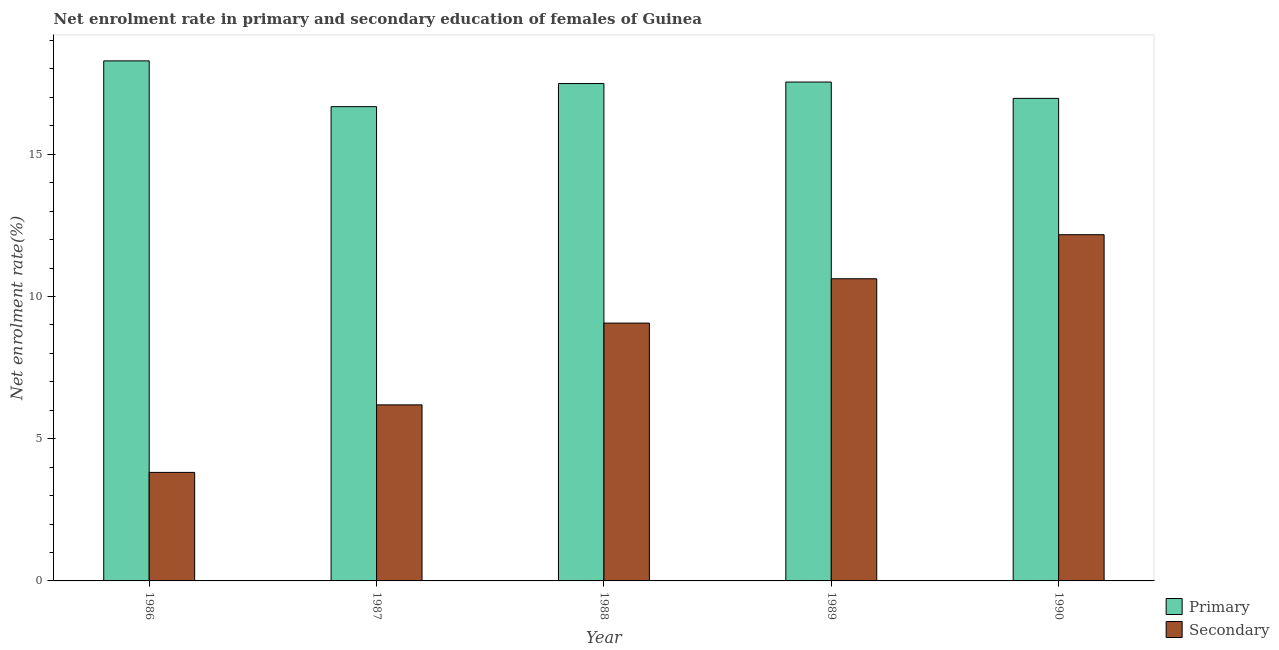How many groups of bars are there?
Offer a very short reply. 5. Are the number of bars per tick equal to the number of legend labels?
Provide a succinct answer. Yes. How many bars are there on the 3rd tick from the left?
Ensure brevity in your answer.  2. What is the enrollment rate in secondary education in 1988?
Provide a succinct answer. 9.06. Across all years, what is the maximum enrollment rate in primary education?
Your answer should be very brief. 18.28. Across all years, what is the minimum enrollment rate in primary education?
Give a very brief answer. 16.67. What is the total enrollment rate in primary education in the graph?
Your response must be concise. 86.94. What is the difference between the enrollment rate in secondary education in 1986 and that in 1989?
Your answer should be very brief. -6.81. What is the difference between the enrollment rate in primary education in 1986 and the enrollment rate in secondary education in 1987?
Make the answer very short. 1.61. What is the average enrollment rate in secondary education per year?
Give a very brief answer. 8.37. In the year 1990, what is the difference between the enrollment rate in primary education and enrollment rate in secondary education?
Provide a succinct answer. 0. In how many years, is the enrollment rate in secondary education greater than 4 %?
Offer a terse response. 4. What is the ratio of the enrollment rate in secondary education in 1986 to that in 1989?
Provide a succinct answer. 0.36. Is the enrollment rate in secondary education in 1987 less than that in 1988?
Provide a short and direct response. Yes. What is the difference between the highest and the second highest enrollment rate in secondary education?
Your answer should be very brief. 1.55. What is the difference between the highest and the lowest enrollment rate in secondary education?
Provide a succinct answer. 8.36. Is the sum of the enrollment rate in secondary education in 1986 and 1988 greater than the maximum enrollment rate in primary education across all years?
Make the answer very short. Yes. What does the 1st bar from the left in 1988 represents?
Your answer should be very brief. Primary. What does the 2nd bar from the right in 1986 represents?
Offer a terse response. Primary. How many bars are there?
Give a very brief answer. 10. How many legend labels are there?
Your answer should be very brief. 2. What is the title of the graph?
Ensure brevity in your answer.  Net enrolment rate in primary and secondary education of females of Guinea. Does "Study and work" appear as one of the legend labels in the graph?
Keep it short and to the point. No. What is the label or title of the X-axis?
Give a very brief answer. Year. What is the label or title of the Y-axis?
Give a very brief answer. Net enrolment rate(%). What is the Net enrolment rate(%) of Primary in 1986?
Provide a succinct answer. 18.28. What is the Net enrolment rate(%) in Secondary in 1986?
Give a very brief answer. 3.81. What is the Net enrolment rate(%) in Primary in 1987?
Offer a very short reply. 16.67. What is the Net enrolment rate(%) of Secondary in 1987?
Give a very brief answer. 6.19. What is the Net enrolment rate(%) of Primary in 1988?
Your answer should be compact. 17.48. What is the Net enrolment rate(%) of Secondary in 1988?
Ensure brevity in your answer.  9.06. What is the Net enrolment rate(%) in Primary in 1989?
Provide a short and direct response. 17.54. What is the Net enrolment rate(%) in Secondary in 1989?
Offer a terse response. 10.62. What is the Net enrolment rate(%) of Primary in 1990?
Your response must be concise. 16.96. What is the Net enrolment rate(%) of Secondary in 1990?
Provide a succinct answer. 12.17. Across all years, what is the maximum Net enrolment rate(%) of Primary?
Give a very brief answer. 18.28. Across all years, what is the maximum Net enrolment rate(%) of Secondary?
Give a very brief answer. 12.17. Across all years, what is the minimum Net enrolment rate(%) of Primary?
Offer a very short reply. 16.67. Across all years, what is the minimum Net enrolment rate(%) in Secondary?
Provide a succinct answer. 3.81. What is the total Net enrolment rate(%) in Primary in the graph?
Your answer should be very brief. 86.94. What is the total Net enrolment rate(%) of Secondary in the graph?
Keep it short and to the point. 41.86. What is the difference between the Net enrolment rate(%) of Primary in 1986 and that in 1987?
Your answer should be very brief. 1.61. What is the difference between the Net enrolment rate(%) in Secondary in 1986 and that in 1987?
Provide a short and direct response. -2.37. What is the difference between the Net enrolment rate(%) of Primary in 1986 and that in 1988?
Offer a terse response. 0.8. What is the difference between the Net enrolment rate(%) in Secondary in 1986 and that in 1988?
Provide a succinct answer. -5.25. What is the difference between the Net enrolment rate(%) of Primary in 1986 and that in 1989?
Provide a short and direct response. 0.74. What is the difference between the Net enrolment rate(%) in Secondary in 1986 and that in 1989?
Your response must be concise. -6.81. What is the difference between the Net enrolment rate(%) in Primary in 1986 and that in 1990?
Your response must be concise. 1.32. What is the difference between the Net enrolment rate(%) of Secondary in 1986 and that in 1990?
Offer a very short reply. -8.36. What is the difference between the Net enrolment rate(%) in Primary in 1987 and that in 1988?
Offer a terse response. -0.81. What is the difference between the Net enrolment rate(%) in Secondary in 1987 and that in 1988?
Ensure brevity in your answer.  -2.87. What is the difference between the Net enrolment rate(%) in Primary in 1987 and that in 1989?
Keep it short and to the point. -0.87. What is the difference between the Net enrolment rate(%) in Secondary in 1987 and that in 1989?
Ensure brevity in your answer.  -4.43. What is the difference between the Net enrolment rate(%) of Primary in 1987 and that in 1990?
Offer a terse response. -0.29. What is the difference between the Net enrolment rate(%) in Secondary in 1987 and that in 1990?
Your answer should be very brief. -5.98. What is the difference between the Net enrolment rate(%) in Primary in 1988 and that in 1989?
Make the answer very short. -0.05. What is the difference between the Net enrolment rate(%) in Secondary in 1988 and that in 1989?
Make the answer very short. -1.56. What is the difference between the Net enrolment rate(%) of Primary in 1988 and that in 1990?
Offer a terse response. 0.52. What is the difference between the Net enrolment rate(%) of Secondary in 1988 and that in 1990?
Keep it short and to the point. -3.11. What is the difference between the Net enrolment rate(%) of Primary in 1989 and that in 1990?
Make the answer very short. 0.57. What is the difference between the Net enrolment rate(%) of Secondary in 1989 and that in 1990?
Keep it short and to the point. -1.55. What is the difference between the Net enrolment rate(%) in Primary in 1986 and the Net enrolment rate(%) in Secondary in 1987?
Give a very brief answer. 12.09. What is the difference between the Net enrolment rate(%) in Primary in 1986 and the Net enrolment rate(%) in Secondary in 1988?
Your answer should be very brief. 9.22. What is the difference between the Net enrolment rate(%) in Primary in 1986 and the Net enrolment rate(%) in Secondary in 1989?
Provide a succinct answer. 7.66. What is the difference between the Net enrolment rate(%) of Primary in 1986 and the Net enrolment rate(%) of Secondary in 1990?
Your answer should be very brief. 6.11. What is the difference between the Net enrolment rate(%) of Primary in 1987 and the Net enrolment rate(%) of Secondary in 1988?
Ensure brevity in your answer.  7.61. What is the difference between the Net enrolment rate(%) in Primary in 1987 and the Net enrolment rate(%) in Secondary in 1989?
Make the answer very short. 6.05. What is the difference between the Net enrolment rate(%) of Primary in 1987 and the Net enrolment rate(%) of Secondary in 1990?
Ensure brevity in your answer.  4.5. What is the difference between the Net enrolment rate(%) in Primary in 1988 and the Net enrolment rate(%) in Secondary in 1989?
Keep it short and to the point. 6.86. What is the difference between the Net enrolment rate(%) of Primary in 1988 and the Net enrolment rate(%) of Secondary in 1990?
Give a very brief answer. 5.31. What is the difference between the Net enrolment rate(%) of Primary in 1989 and the Net enrolment rate(%) of Secondary in 1990?
Make the answer very short. 5.37. What is the average Net enrolment rate(%) of Primary per year?
Your response must be concise. 17.39. What is the average Net enrolment rate(%) in Secondary per year?
Offer a very short reply. 8.37. In the year 1986, what is the difference between the Net enrolment rate(%) of Primary and Net enrolment rate(%) of Secondary?
Ensure brevity in your answer.  14.47. In the year 1987, what is the difference between the Net enrolment rate(%) of Primary and Net enrolment rate(%) of Secondary?
Make the answer very short. 10.48. In the year 1988, what is the difference between the Net enrolment rate(%) of Primary and Net enrolment rate(%) of Secondary?
Make the answer very short. 8.42. In the year 1989, what is the difference between the Net enrolment rate(%) of Primary and Net enrolment rate(%) of Secondary?
Keep it short and to the point. 6.92. In the year 1990, what is the difference between the Net enrolment rate(%) in Primary and Net enrolment rate(%) in Secondary?
Keep it short and to the point. 4.79. What is the ratio of the Net enrolment rate(%) of Primary in 1986 to that in 1987?
Provide a succinct answer. 1.1. What is the ratio of the Net enrolment rate(%) of Secondary in 1986 to that in 1987?
Your response must be concise. 0.62. What is the ratio of the Net enrolment rate(%) of Primary in 1986 to that in 1988?
Your answer should be compact. 1.05. What is the ratio of the Net enrolment rate(%) of Secondary in 1986 to that in 1988?
Provide a succinct answer. 0.42. What is the ratio of the Net enrolment rate(%) of Primary in 1986 to that in 1989?
Give a very brief answer. 1.04. What is the ratio of the Net enrolment rate(%) of Secondary in 1986 to that in 1989?
Your answer should be compact. 0.36. What is the ratio of the Net enrolment rate(%) of Primary in 1986 to that in 1990?
Give a very brief answer. 1.08. What is the ratio of the Net enrolment rate(%) of Secondary in 1986 to that in 1990?
Your response must be concise. 0.31. What is the ratio of the Net enrolment rate(%) in Primary in 1987 to that in 1988?
Make the answer very short. 0.95. What is the ratio of the Net enrolment rate(%) in Secondary in 1987 to that in 1988?
Make the answer very short. 0.68. What is the ratio of the Net enrolment rate(%) of Primary in 1987 to that in 1989?
Provide a short and direct response. 0.95. What is the ratio of the Net enrolment rate(%) of Secondary in 1987 to that in 1989?
Keep it short and to the point. 0.58. What is the ratio of the Net enrolment rate(%) in Primary in 1987 to that in 1990?
Offer a very short reply. 0.98. What is the ratio of the Net enrolment rate(%) of Secondary in 1987 to that in 1990?
Offer a very short reply. 0.51. What is the ratio of the Net enrolment rate(%) of Primary in 1988 to that in 1989?
Your response must be concise. 1. What is the ratio of the Net enrolment rate(%) of Secondary in 1988 to that in 1989?
Make the answer very short. 0.85. What is the ratio of the Net enrolment rate(%) of Primary in 1988 to that in 1990?
Offer a very short reply. 1.03. What is the ratio of the Net enrolment rate(%) of Secondary in 1988 to that in 1990?
Your answer should be very brief. 0.74. What is the ratio of the Net enrolment rate(%) of Primary in 1989 to that in 1990?
Ensure brevity in your answer.  1.03. What is the ratio of the Net enrolment rate(%) of Secondary in 1989 to that in 1990?
Your response must be concise. 0.87. What is the difference between the highest and the second highest Net enrolment rate(%) of Primary?
Give a very brief answer. 0.74. What is the difference between the highest and the second highest Net enrolment rate(%) in Secondary?
Make the answer very short. 1.55. What is the difference between the highest and the lowest Net enrolment rate(%) of Primary?
Your answer should be very brief. 1.61. What is the difference between the highest and the lowest Net enrolment rate(%) in Secondary?
Your answer should be very brief. 8.36. 